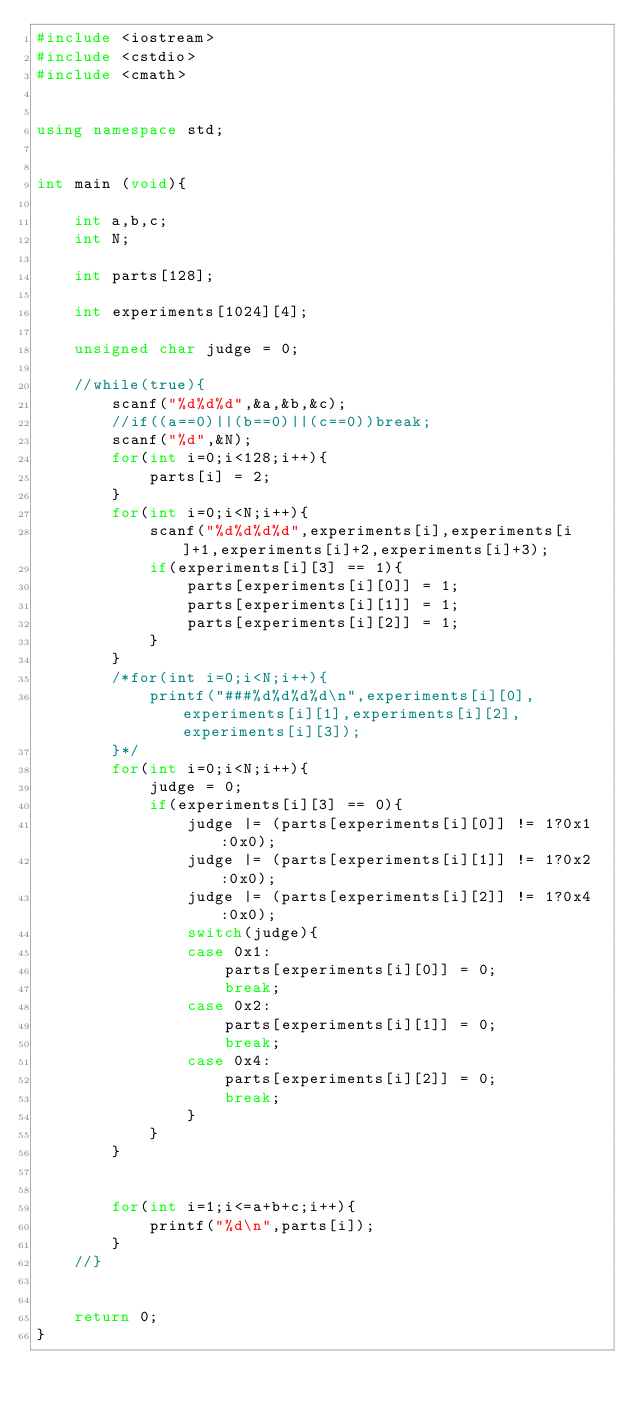<code> <loc_0><loc_0><loc_500><loc_500><_C++_>#include <iostream>
#include <cstdio>
#include <cmath>


using namespace std;


int main (void){

	int a,b,c;
	int N;

	int parts[128];

	int experiments[1024][4];

	unsigned char judge = 0;

	//while(true){
		scanf("%d%d%d",&a,&b,&c);
		//if((a==0)||(b==0)||(c==0))break;
		scanf("%d",&N);
		for(int i=0;i<128;i++){
			parts[i] = 2;
		}
		for(int i=0;i<N;i++){
			scanf("%d%d%d%d",experiments[i],experiments[i]+1,experiments[i]+2,experiments[i]+3);
			if(experiments[i][3] == 1){
				parts[experiments[i][0]] = 1;
				parts[experiments[i][1]] = 1;
				parts[experiments[i][2]] = 1;
			}
		}
		/*for(int i=0;i<N;i++){
			printf("###%d%d%d%d\n",experiments[i][0],experiments[i][1],experiments[i][2],experiments[i][3]);
		}*/
		for(int i=0;i<N;i++){
			judge = 0;
			if(experiments[i][3] == 0){
				judge |= (parts[experiments[i][0]] != 1?0x1:0x0);
				judge |= (parts[experiments[i][1]] != 1?0x2:0x0);
				judge |= (parts[experiments[i][2]] != 1?0x4:0x0);
				switch(judge){
				case 0x1:
					parts[experiments[i][0]] = 0;
					break;
				case 0x2:
					parts[experiments[i][1]] = 0;
					break;
				case 0x4:
					parts[experiments[i][2]] = 0;
					break;
				}
			}
		}


		for(int i=1;i<=a+b+c;i++){
			printf("%d\n",parts[i]);
		}
	//}


	return 0;
}</code> 